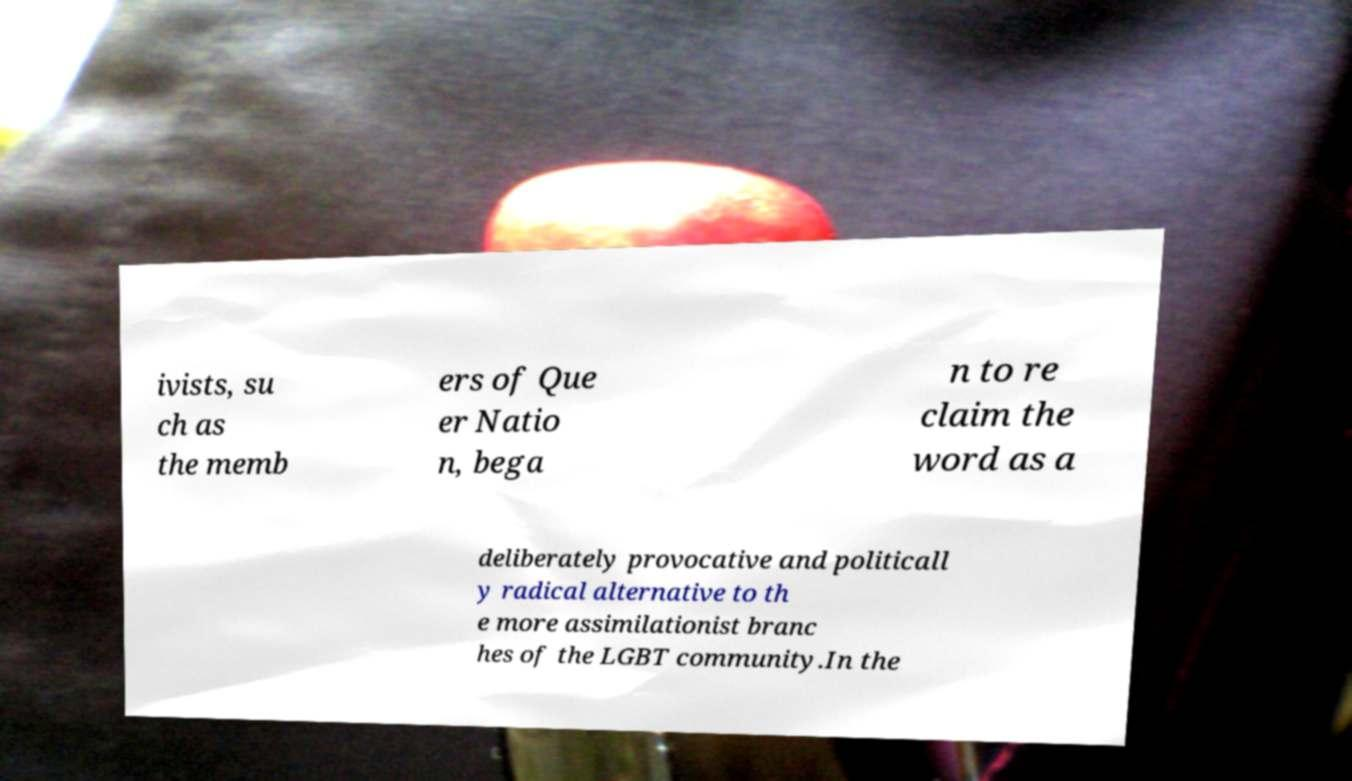There's text embedded in this image that I need extracted. Can you transcribe it verbatim? ivists, su ch as the memb ers of Que er Natio n, bega n to re claim the word as a deliberately provocative and politicall y radical alternative to th e more assimilationist branc hes of the LGBT community.In the 